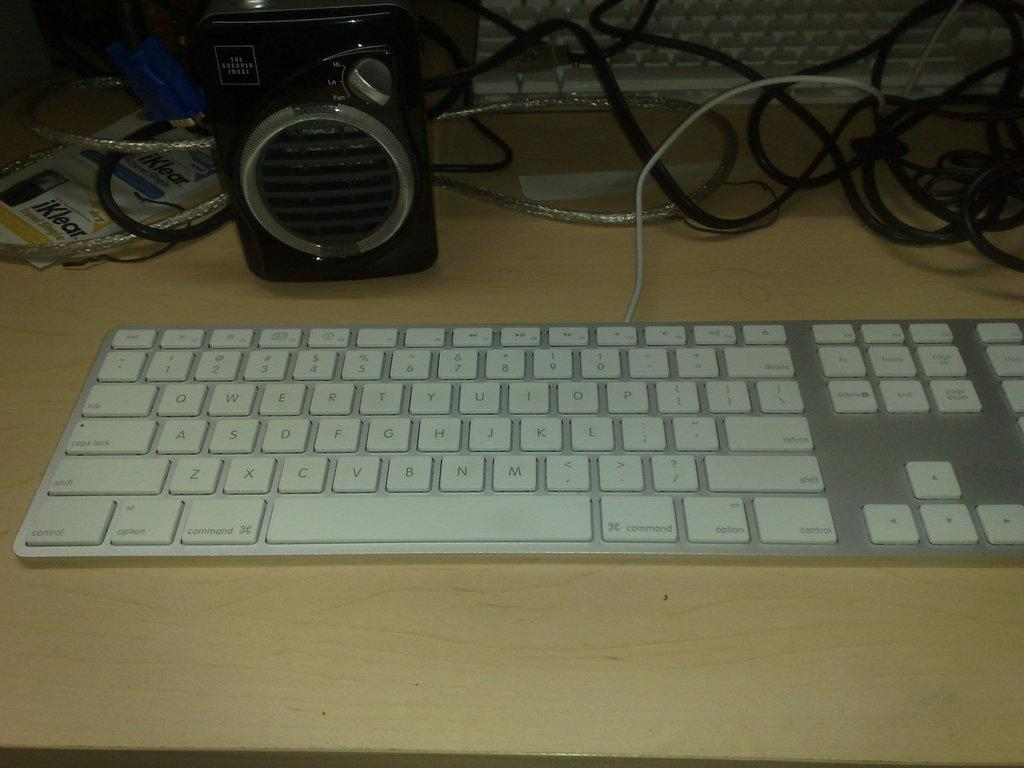What type of input device is visible in the image? There is a computer keyboard in the image. What is used for audio output in the image? There are speakers in the image. Are there any visible connections between the devices in the image? Yes, cables are visible in the image. What is the surface on which the devices are placed? The objects are on a wooden surface. Can you describe the design of the squirrel sitting on the keyboard in the image? There is no squirrel present in the image; it only features a computer keyboard, speakers, and cables on a wooden surface. 